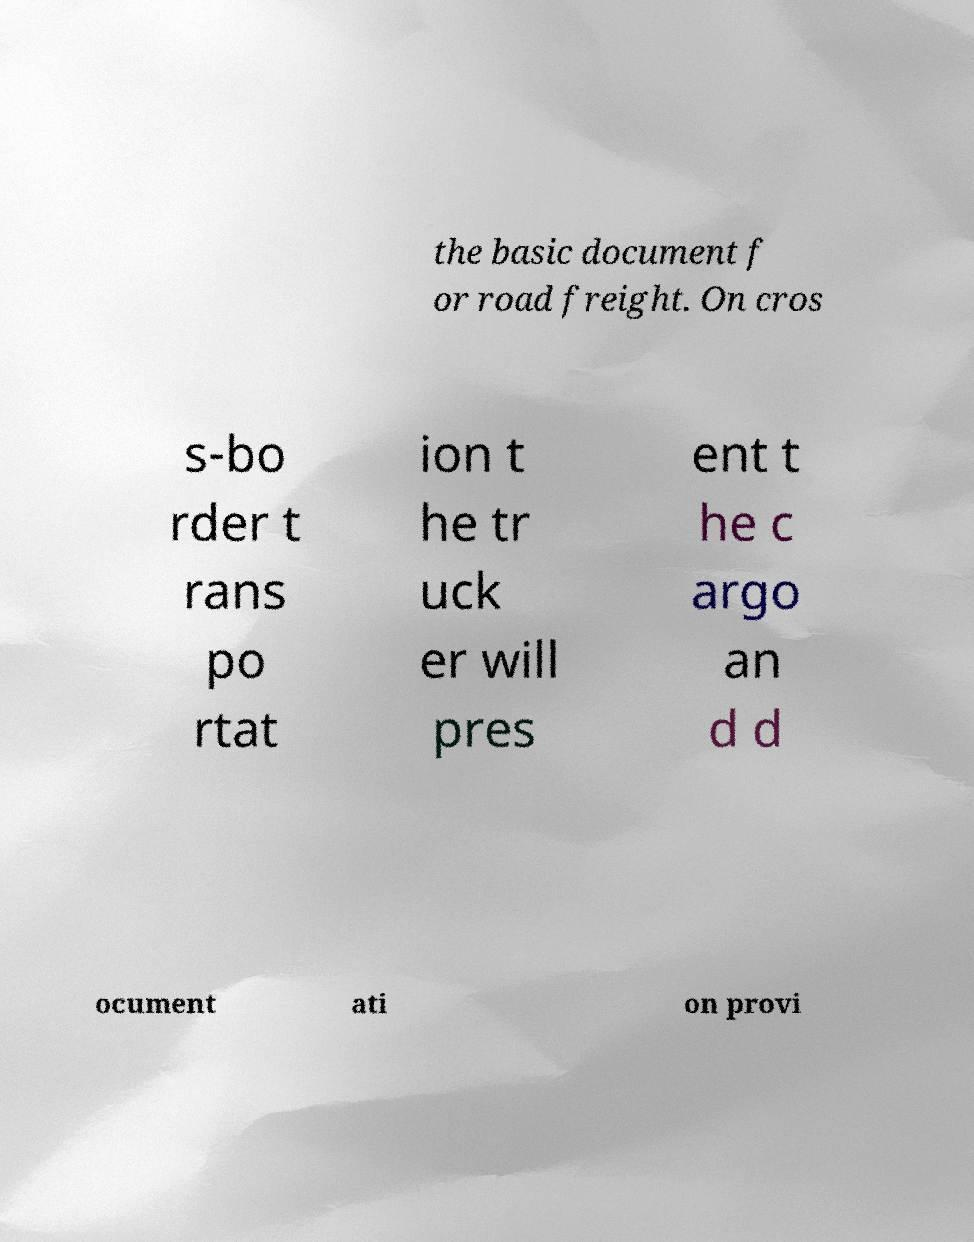Please identify and transcribe the text found in this image. the basic document f or road freight. On cros s-bo rder t rans po rtat ion t he tr uck er will pres ent t he c argo an d d ocument ati on provi 